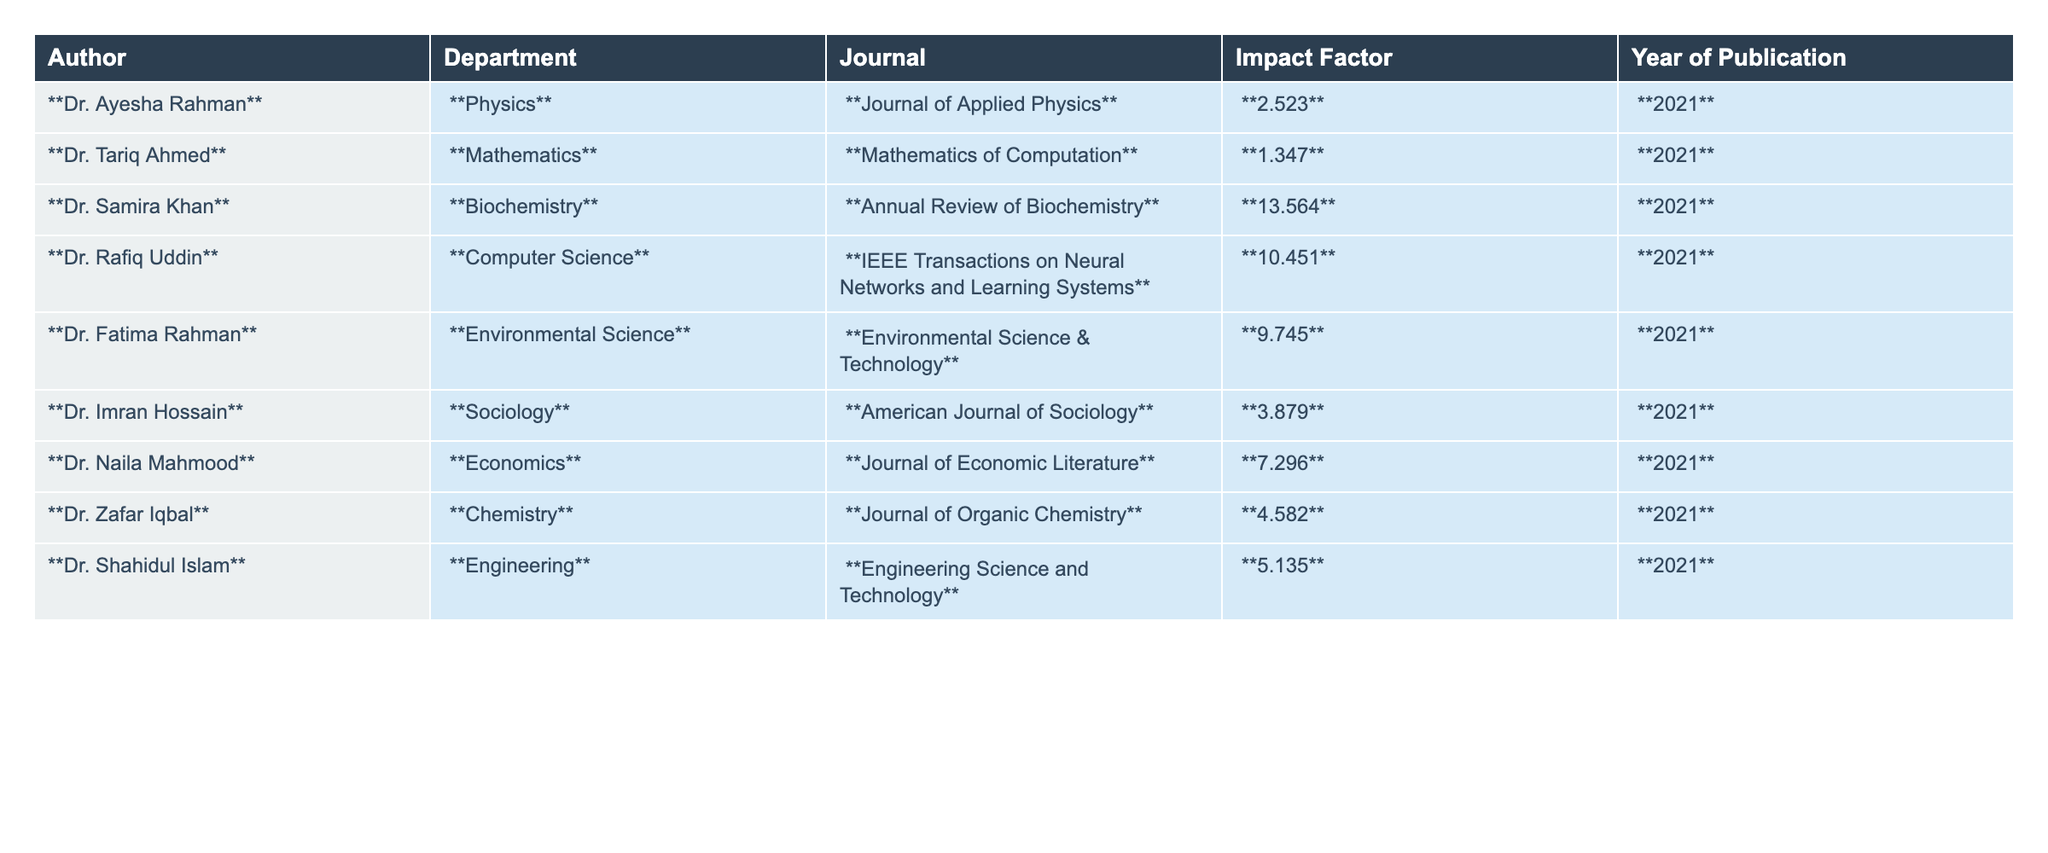What is the highest Impact Factor listed in the table? Looking at the Impact Factor column, we can identify the highest value. The values are 2.523, 1.347, 13.564, 10.451, 9.745, 3.879, 7.296, 4.582, and 5.135. The highest among these is 13.564.
Answer: 13.564 Which journal has the lowest Impact Factor among the listed publications? To find the lowest Impact Factor, we examine the values in the Impact Factor column: 2.523, 1.347, 13.564, 10.451, 9.745, 3.879, 7.296, 4.582, and 5.135. The lowest value is 1.347, corresponding to the journal Mathematics of Computation.
Answer: Mathematics of Computation How many departments have an Impact Factor greater than 5? We can look at the Impact Factors and count those greater than 5. The relevant values are 13.564, 10.451, 9.745, 7.296, 5.135. There are five departments with Impact Factors above 5.
Answer: 5 Which author from the table belongs to the Environmental Science department? Scanning the department column, Dr. Fatima Rahman is listed under Environmental Science with an Impact Factor of 9.745.
Answer: Dr. Fatima Rahman Calculate the average Impact Factor of all the authors listed. To calculate the average, we sum the Impact Factors: 2.523 + 1.347 + 13.564 + 10.451 + 9.745 + 3.879 + 7.296 + 4.582 + 5.135 = 54.522. There are 9 authors, so the average is 54.522 / 9 = 6.058.
Answer: 6.058 Is there any author in the Computer Science department with an Impact Factor lower than 5? The Impact Factor for Dr. Rafiq Uddin from the Computer Science department is 10.451. There are no values for this department under 5, leading to a conclusion that the statement is false.
Answer: No Which department has the author with the highest Impact Factor? Dr. Samira Khan from the Biochemistry department has the highest Impact Factor of 13.564. This indicates that the Biochemistry department is where the author with the highest Impact Factor is found.
Answer: Biochemistry What is the total Impact Factor of the publications from the Chemistry and Economics departments? The Impact Factor from the Chemistry department (Dr. Zafar Iqbal) is 4.582, and from the Economics department (Dr. Naila Mahmood) is 7.296. Adding these gives us a total of 4.582 + 7.296 = 11.878.
Answer: 11.878 